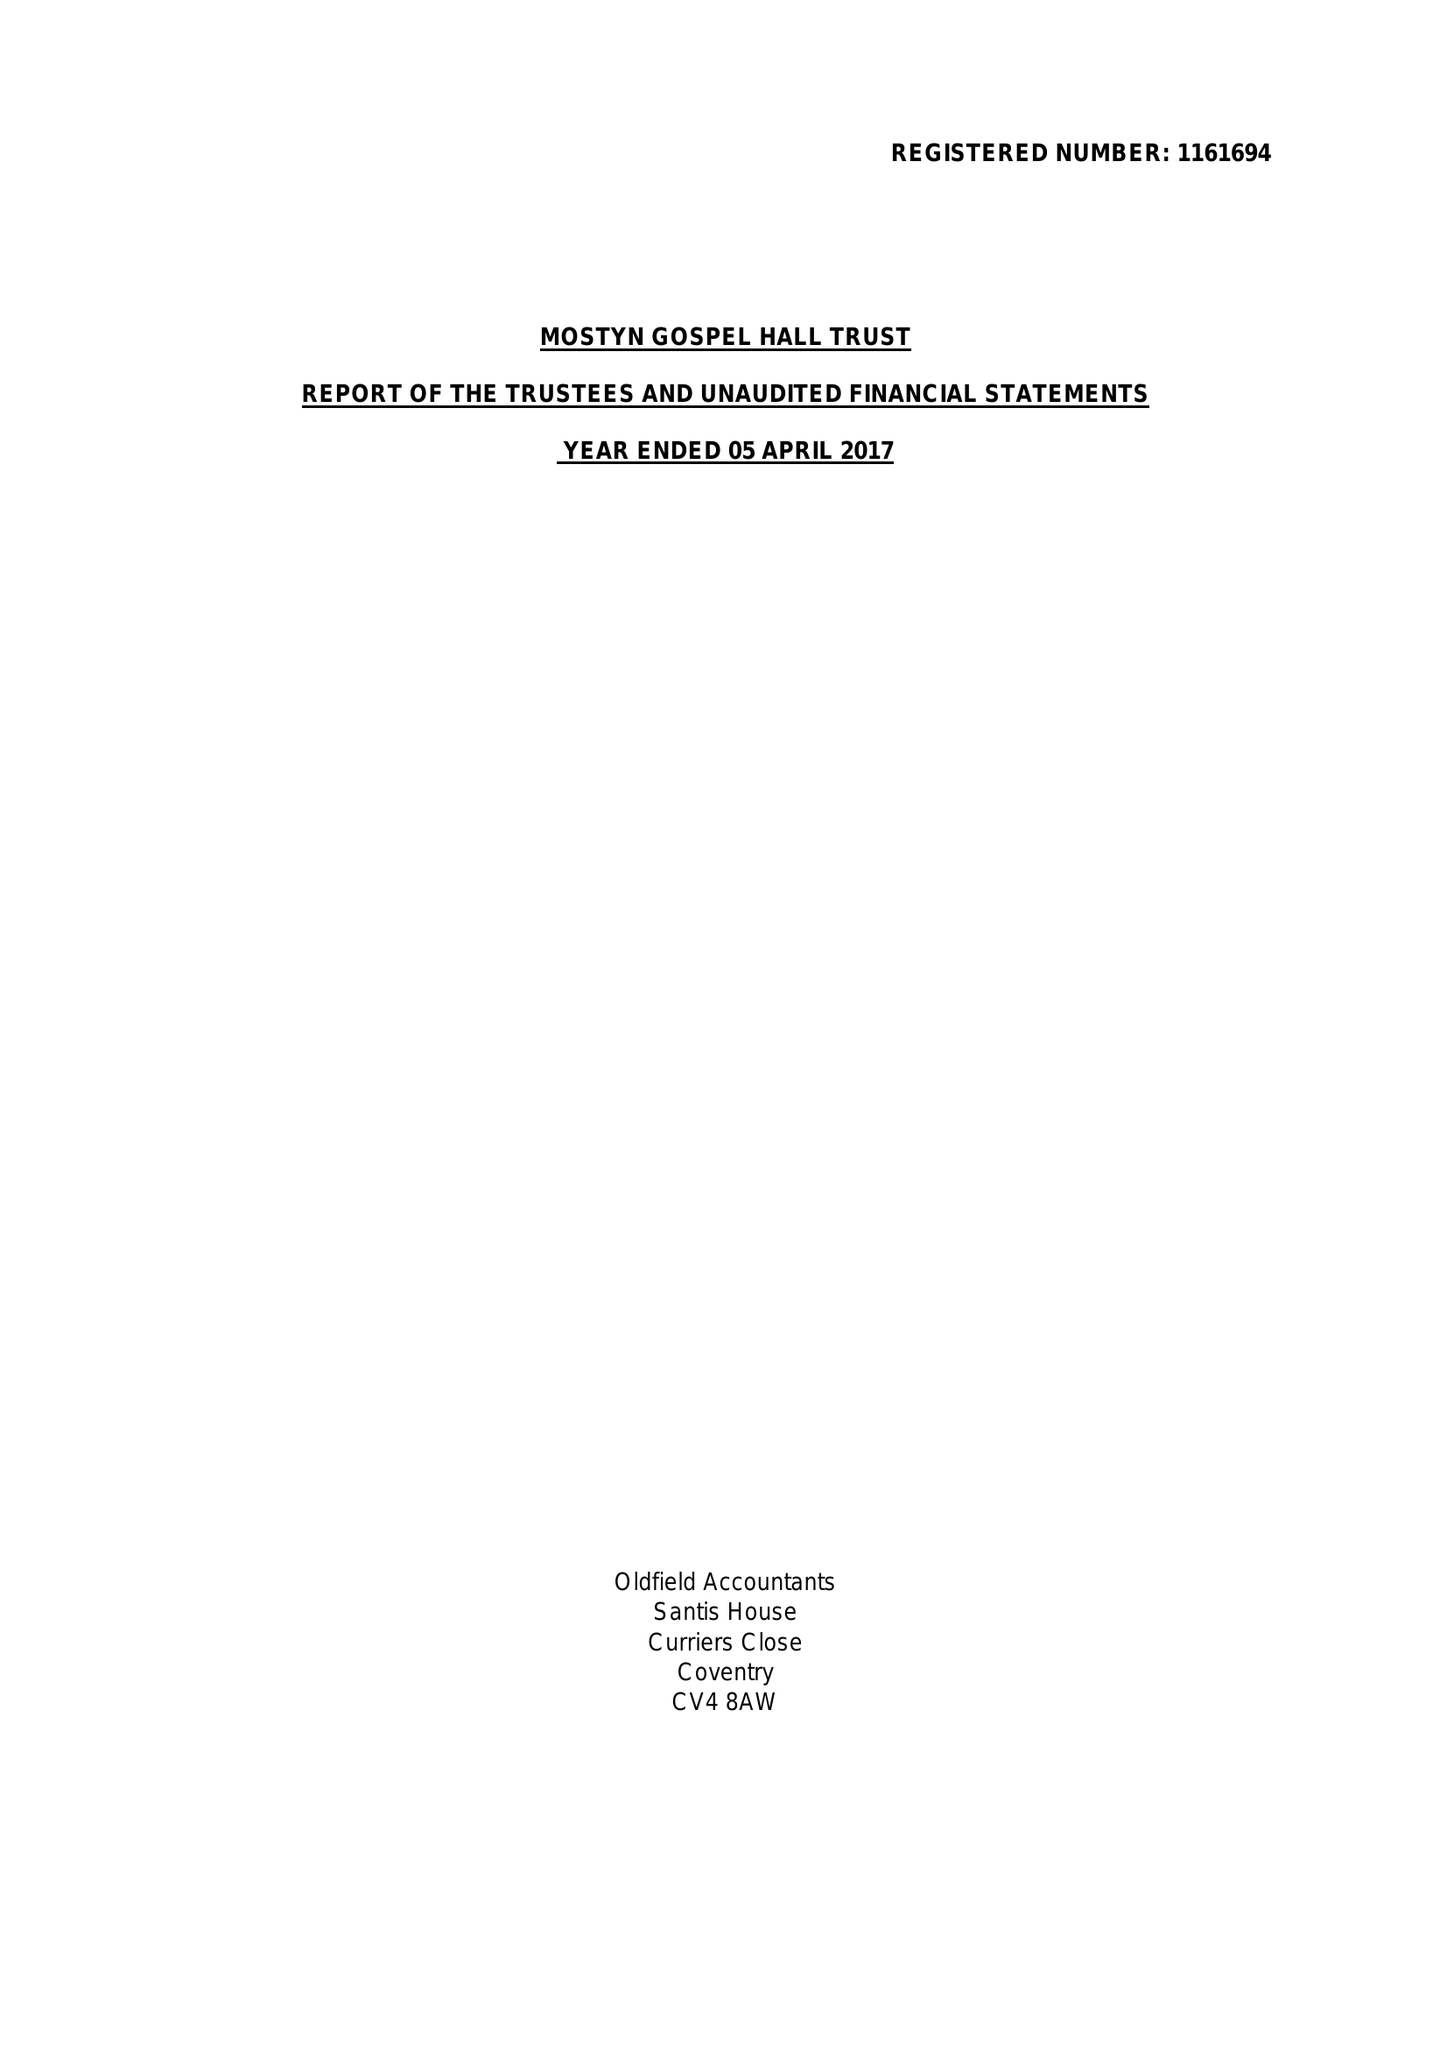What is the value for the spending_annually_in_british_pounds?
Answer the question using a single word or phrase. 44549.00 